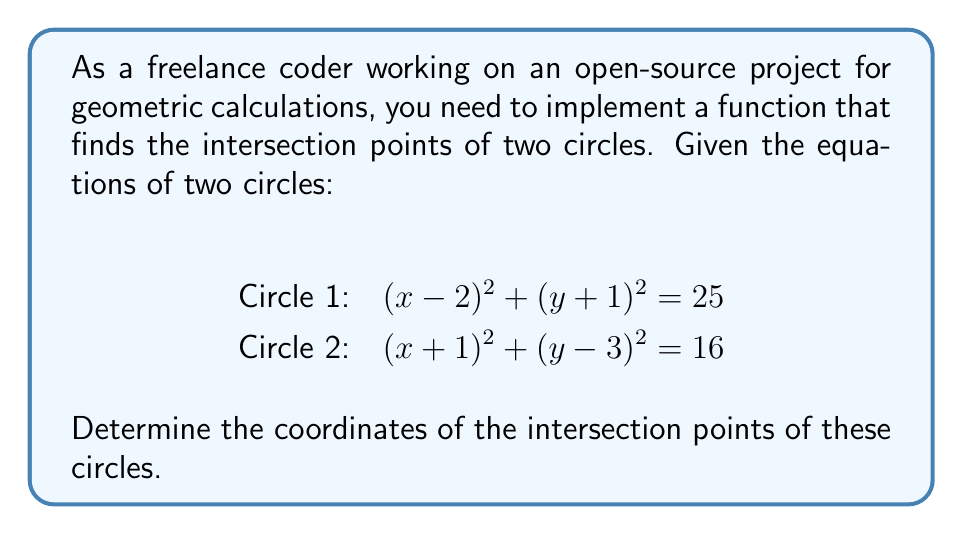Give your solution to this math problem. To find the intersection points of the two circles, we'll follow these steps:

1) Expand the equations of both circles:
   Circle 1: $x^2 - 4x + 4 + y^2 + 2y + 1 = 25$
   Circle 2: $x^2 + 2x + 1 + y^2 - 6y + 9 = 16$

2) Simplify:
   Circle 1: $x^2 + y^2 - 4x + 2y - 20 = 0$ ... (1)
   Circle 2: $x^2 + y^2 + 2x - 6y - 6 = 0$ ... (2)

3) Subtract equation (2) from equation (1) to eliminate $x^2$ and $y^2$:
   $-6x + 8y - 14 = 0$

4) Solve this equation for y:
   $y = \frac{3x + 7}{4}$ ... (3)

5) Substitute this expression for y into equation (1):
   $x^2 + (\frac{3x + 7}{4})^2 - 4x + 2(\frac{3x + 7}{4}) - 20 = 0$

6) Multiply everything by 16 to eliminate fractions:
   $16x^2 + (3x + 7)^2 - 64x + 8(3x + 7) - 320 = 0$

7) Expand:
   $16x^2 + 9x^2 + 42x + 49 - 64x + 24x + 56 - 320 = 0$
   $25x^2 + 2x - 215 = 0$

8) Solve this quadratic equation:
   $x = \frac{-2 \pm \sqrt{4 + 4(25)(215)}}{2(25)} = \frac{-2 \pm \sqrt{21504}}{50} = \frac{-1 \pm 73}{25}$

9) Therefore, $x_1 = \frac{72}{25} = 2.88$ and $x_2 = -\frac{74}{25} = -2.96$

10) Substitute these x-values into equation (3) to find the corresponding y-values:
    For $x_1$: $y_1 = \frac{3(2.88) + 7}{4} = 3.66$
    For $x_2$: $y_2 = \frac{3(-2.96) + 7}{4} = -0.47$

Therefore, the intersection points are (2.88, 3.66) and (-2.96, -0.47).
Answer: (2.88, 3.66) and (-2.96, -0.47) 